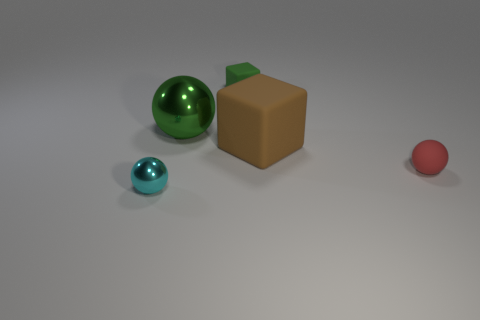Add 5 matte balls. How many objects exist? 10 Subtract all spheres. How many objects are left? 2 Add 4 large matte objects. How many large matte objects are left? 5 Add 3 tiny cyan balls. How many tiny cyan balls exist? 4 Subtract 0 yellow spheres. How many objects are left? 5 Subtract all big brown objects. Subtract all green spheres. How many objects are left? 3 